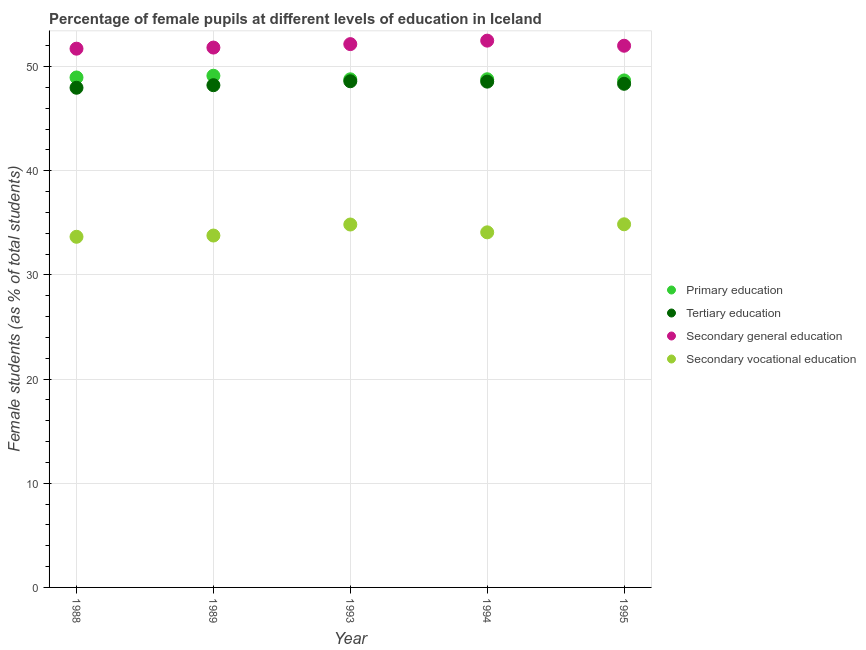Is the number of dotlines equal to the number of legend labels?
Your answer should be very brief. Yes. What is the percentage of female students in secondary vocational education in 1995?
Your answer should be compact. 34.86. Across all years, what is the maximum percentage of female students in primary education?
Your answer should be compact. 49.11. Across all years, what is the minimum percentage of female students in secondary education?
Ensure brevity in your answer.  51.71. In which year was the percentage of female students in tertiary education maximum?
Offer a very short reply. 1993. In which year was the percentage of female students in primary education minimum?
Ensure brevity in your answer.  1995. What is the total percentage of female students in primary education in the graph?
Offer a very short reply. 244.28. What is the difference between the percentage of female students in tertiary education in 1993 and that in 1994?
Offer a very short reply. 0.04. What is the difference between the percentage of female students in secondary vocational education in 1994 and the percentage of female students in tertiary education in 1995?
Your answer should be compact. -14.26. What is the average percentage of female students in secondary education per year?
Your answer should be compact. 52.03. In the year 1989, what is the difference between the percentage of female students in tertiary education and percentage of female students in primary education?
Offer a terse response. -0.91. In how many years, is the percentage of female students in primary education greater than 34 %?
Give a very brief answer. 5. What is the ratio of the percentage of female students in tertiary education in 1988 to that in 1995?
Offer a very short reply. 0.99. Is the percentage of female students in tertiary education in 1989 less than that in 1995?
Your response must be concise. Yes. What is the difference between the highest and the second highest percentage of female students in secondary education?
Give a very brief answer. 0.34. What is the difference between the highest and the lowest percentage of female students in tertiary education?
Ensure brevity in your answer.  0.62. Is the sum of the percentage of female students in primary education in 1988 and 1995 greater than the maximum percentage of female students in secondary education across all years?
Provide a short and direct response. Yes. Is the percentage of female students in secondary education strictly less than the percentage of female students in tertiary education over the years?
Give a very brief answer. No. How many dotlines are there?
Provide a short and direct response. 4. How many years are there in the graph?
Provide a short and direct response. 5. How are the legend labels stacked?
Give a very brief answer. Vertical. What is the title of the graph?
Your answer should be compact. Percentage of female pupils at different levels of education in Iceland. What is the label or title of the Y-axis?
Your answer should be compact. Female students (as % of total students). What is the Female students (as % of total students) of Primary education in 1988?
Give a very brief answer. 48.95. What is the Female students (as % of total students) in Tertiary education in 1988?
Your answer should be compact. 47.96. What is the Female students (as % of total students) in Secondary general education in 1988?
Give a very brief answer. 51.71. What is the Female students (as % of total students) of Secondary vocational education in 1988?
Provide a succinct answer. 33.66. What is the Female students (as % of total students) of Primary education in 1989?
Give a very brief answer. 49.11. What is the Female students (as % of total students) in Tertiary education in 1989?
Keep it short and to the point. 48.21. What is the Female students (as % of total students) in Secondary general education in 1989?
Make the answer very short. 51.82. What is the Female students (as % of total students) of Secondary vocational education in 1989?
Make the answer very short. 33.78. What is the Female students (as % of total students) of Primary education in 1993?
Your answer should be very brief. 48.77. What is the Female students (as % of total students) in Tertiary education in 1993?
Provide a short and direct response. 48.59. What is the Female students (as % of total students) of Secondary general education in 1993?
Make the answer very short. 52.15. What is the Female students (as % of total students) of Secondary vocational education in 1993?
Offer a terse response. 34.83. What is the Female students (as % of total students) in Primary education in 1994?
Your answer should be compact. 48.78. What is the Female students (as % of total students) of Tertiary education in 1994?
Your answer should be compact. 48.55. What is the Female students (as % of total students) in Secondary general education in 1994?
Offer a very short reply. 52.49. What is the Female students (as % of total students) of Secondary vocational education in 1994?
Make the answer very short. 34.08. What is the Female students (as % of total students) of Primary education in 1995?
Offer a terse response. 48.66. What is the Female students (as % of total students) of Tertiary education in 1995?
Provide a succinct answer. 48.34. What is the Female students (as % of total students) in Secondary general education in 1995?
Provide a succinct answer. 52. What is the Female students (as % of total students) of Secondary vocational education in 1995?
Offer a terse response. 34.86. Across all years, what is the maximum Female students (as % of total students) in Primary education?
Provide a succinct answer. 49.11. Across all years, what is the maximum Female students (as % of total students) of Tertiary education?
Your response must be concise. 48.59. Across all years, what is the maximum Female students (as % of total students) in Secondary general education?
Provide a succinct answer. 52.49. Across all years, what is the maximum Female students (as % of total students) of Secondary vocational education?
Keep it short and to the point. 34.86. Across all years, what is the minimum Female students (as % of total students) of Primary education?
Offer a very short reply. 48.66. Across all years, what is the minimum Female students (as % of total students) in Tertiary education?
Give a very brief answer. 47.96. Across all years, what is the minimum Female students (as % of total students) in Secondary general education?
Your answer should be compact. 51.71. Across all years, what is the minimum Female students (as % of total students) of Secondary vocational education?
Give a very brief answer. 33.66. What is the total Female students (as % of total students) of Primary education in the graph?
Your answer should be very brief. 244.28. What is the total Female students (as % of total students) of Tertiary education in the graph?
Keep it short and to the point. 241.65. What is the total Female students (as % of total students) in Secondary general education in the graph?
Your answer should be compact. 260.16. What is the total Female students (as % of total students) in Secondary vocational education in the graph?
Your answer should be very brief. 171.21. What is the difference between the Female students (as % of total students) of Primary education in 1988 and that in 1989?
Provide a succinct answer. -0.17. What is the difference between the Female students (as % of total students) in Tertiary education in 1988 and that in 1989?
Your answer should be compact. -0.25. What is the difference between the Female students (as % of total students) of Secondary general education in 1988 and that in 1989?
Offer a terse response. -0.11. What is the difference between the Female students (as % of total students) of Secondary vocational education in 1988 and that in 1989?
Keep it short and to the point. -0.12. What is the difference between the Female students (as % of total students) of Primary education in 1988 and that in 1993?
Ensure brevity in your answer.  0.18. What is the difference between the Female students (as % of total students) in Tertiary education in 1988 and that in 1993?
Your answer should be compact. -0.62. What is the difference between the Female students (as % of total students) in Secondary general education in 1988 and that in 1993?
Your answer should be compact. -0.44. What is the difference between the Female students (as % of total students) in Secondary vocational education in 1988 and that in 1993?
Your answer should be compact. -1.18. What is the difference between the Female students (as % of total students) in Primary education in 1988 and that in 1994?
Ensure brevity in your answer.  0.17. What is the difference between the Female students (as % of total students) of Tertiary education in 1988 and that in 1994?
Ensure brevity in your answer.  -0.59. What is the difference between the Female students (as % of total students) in Secondary general education in 1988 and that in 1994?
Offer a terse response. -0.77. What is the difference between the Female students (as % of total students) in Secondary vocational education in 1988 and that in 1994?
Your answer should be very brief. -0.43. What is the difference between the Female students (as % of total students) in Primary education in 1988 and that in 1995?
Keep it short and to the point. 0.28. What is the difference between the Female students (as % of total students) of Tertiary education in 1988 and that in 1995?
Your answer should be very brief. -0.38. What is the difference between the Female students (as % of total students) of Secondary general education in 1988 and that in 1995?
Provide a short and direct response. -0.28. What is the difference between the Female students (as % of total students) of Secondary vocational education in 1988 and that in 1995?
Offer a terse response. -1.2. What is the difference between the Female students (as % of total students) of Primary education in 1989 and that in 1993?
Your answer should be very brief. 0.34. What is the difference between the Female students (as % of total students) of Tertiary education in 1989 and that in 1993?
Your answer should be very brief. -0.38. What is the difference between the Female students (as % of total students) in Secondary general education in 1989 and that in 1993?
Provide a succinct answer. -0.33. What is the difference between the Female students (as % of total students) in Secondary vocational education in 1989 and that in 1993?
Give a very brief answer. -1.06. What is the difference between the Female students (as % of total students) of Primary education in 1989 and that in 1994?
Give a very brief answer. 0.34. What is the difference between the Female students (as % of total students) of Tertiary education in 1989 and that in 1994?
Offer a very short reply. -0.34. What is the difference between the Female students (as % of total students) of Secondary general education in 1989 and that in 1994?
Provide a short and direct response. -0.67. What is the difference between the Female students (as % of total students) of Secondary vocational education in 1989 and that in 1994?
Your answer should be compact. -0.31. What is the difference between the Female students (as % of total students) of Primary education in 1989 and that in 1995?
Your answer should be very brief. 0.45. What is the difference between the Female students (as % of total students) of Tertiary education in 1989 and that in 1995?
Your response must be concise. -0.13. What is the difference between the Female students (as % of total students) of Secondary general education in 1989 and that in 1995?
Ensure brevity in your answer.  -0.18. What is the difference between the Female students (as % of total students) in Secondary vocational education in 1989 and that in 1995?
Ensure brevity in your answer.  -1.08. What is the difference between the Female students (as % of total students) of Primary education in 1993 and that in 1994?
Offer a very short reply. -0.01. What is the difference between the Female students (as % of total students) in Tertiary education in 1993 and that in 1994?
Your response must be concise. 0.04. What is the difference between the Female students (as % of total students) of Secondary general education in 1993 and that in 1994?
Your answer should be very brief. -0.34. What is the difference between the Female students (as % of total students) in Secondary vocational education in 1993 and that in 1994?
Your response must be concise. 0.75. What is the difference between the Female students (as % of total students) in Primary education in 1993 and that in 1995?
Your answer should be very brief. 0.11. What is the difference between the Female students (as % of total students) of Tertiary education in 1993 and that in 1995?
Offer a terse response. 0.24. What is the difference between the Female students (as % of total students) of Secondary general education in 1993 and that in 1995?
Make the answer very short. 0.16. What is the difference between the Female students (as % of total students) of Secondary vocational education in 1993 and that in 1995?
Your answer should be compact. -0.02. What is the difference between the Female students (as % of total students) in Primary education in 1994 and that in 1995?
Provide a succinct answer. 0.11. What is the difference between the Female students (as % of total students) in Tertiary education in 1994 and that in 1995?
Keep it short and to the point. 0.21. What is the difference between the Female students (as % of total students) of Secondary general education in 1994 and that in 1995?
Give a very brief answer. 0.49. What is the difference between the Female students (as % of total students) in Secondary vocational education in 1994 and that in 1995?
Make the answer very short. -0.77. What is the difference between the Female students (as % of total students) in Primary education in 1988 and the Female students (as % of total students) in Tertiary education in 1989?
Your answer should be very brief. 0.74. What is the difference between the Female students (as % of total students) in Primary education in 1988 and the Female students (as % of total students) in Secondary general education in 1989?
Give a very brief answer. -2.87. What is the difference between the Female students (as % of total students) of Primary education in 1988 and the Female students (as % of total students) of Secondary vocational education in 1989?
Give a very brief answer. 15.17. What is the difference between the Female students (as % of total students) in Tertiary education in 1988 and the Female students (as % of total students) in Secondary general education in 1989?
Your answer should be compact. -3.86. What is the difference between the Female students (as % of total students) in Tertiary education in 1988 and the Female students (as % of total students) in Secondary vocational education in 1989?
Make the answer very short. 14.19. What is the difference between the Female students (as % of total students) of Secondary general education in 1988 and the Female students (as % of total students) of Secondary vocational education in 1989?
Provide a short and direct response. 17.94. What is the difference between the Female students (as % of total students) of Primary education in 1988 and the Female students (as % of total students) of Tertiary education in 1993?
Make the answer very short. 0.36. What is the difference between the Female students (as % of total students) in Primary education in 1988 and the Female students (as % of total students) in Secondary general education in 1993?
Ensure brevity in your answer.  -3.2. What is the difference between the Female students (as % of total students) in Primary education in 1988 and the Female students (as % of total students) in Secondary vocational education in 1993?
Keep it short and to the point. 14.11. What is the difference between the Female students (as % of total students) of Tertiary education in 1988 and the Female students (as % of total students) of Secondary general education in 1993?
Provide a succinct answer. -4.19. What is the difference between the Female students (as % of total students) in Tertiary education in 1988 and the Female students (as % of total students) in Secondary vocational education in 1993?
Provide a short and direct response. 13.13. What is the difference between the Female students (as % of total students) in Secondary general education in 1988 and the Female students (as % of total students) in Secondary vocational education in 1993?
Offer a terse response. 16.88. What is the difference between the Female students (as % of total students) in Primary education in 1988 and the Female students (as % of total students) in Tertiary education in 1994?
Provide a succinct answer. 0.4. What is the difference between the Female students (as % of total students) in Primary education in 1988 and the Female students (as % of total students) in Secondary general education in 1994?
Your response must be concise. -3.54. What is the difference between the Female students (as % of total students) of Primary education in 1988 and the Female students (as % of total students) of Secondary vocational education in 1994?
Give a very brief answer. 14.86. What is the difference between the Female students (as % of total students) in Tertiary education in 1988 and the Female students (as % of total students) in Secondary general education in 1994?
Provide a short and direct response. -4.52. What is the difference between the Female students (as % of total students) of Tertiary education in 1988 and the Female students (as % of total students) of Secondary vocational education in 1994?
Your response must be concise. 13.88. What is the difference between the Female students (as % of total students) in Secondary general education in 1988 and the Female students (as % of total students) in Secondary vocational education in 1994?
Make the answer very short. 17.63. What is the difference between the Female students (as % of total students) in Primary education in 1988 and the Female students (as % of total students) in Tertiary education in 1995?
Keep it short and to the point. 0.61. What is the difference between the Female students (as % of total students) in Primary education in 1988 and the Female students (as % of total students) in Secondary general education in 1995?
Your response must be concise. -3.05. What is the difference between the Female students (as % of total students) of Primary education in 1988 and the Female students (as % of total students) of Secondary vocational education in 1995?
Ensure brevity in your answer.  14.09. What is the difference between the Female students (as % of total students) of Tertiary education in 1988 and the Female students (as % of total students) of Secondary general education in 1995?
Keep it short and to the point. -4.03. What is the difference between the Female students (as % of total students) of Tertiary education in 1988 and the Female students (as % of total students) of Secondary vocational education in 1995?
Provide a short and direct response. 13.1. What is the difference between the Female students (as % of total students) of Secondary general education in 1988 and the Female students (as % of total students) of Secondary vocational education in 1995?
Provide a succinct answer. 16.86. What is the difference between the Female students (as % of total students) of Primary education in 1989 and the Female students (as % of total students) of Tertiary education in 1993?
Your answer should be very brief. 0.53. What is the difference between the Female students (as % of total students) in Primary education in 1989 and the Female students (as % of total students) in Secondary general education in 1993?
Provide a succinct answer. -3.04. What is the difference between the Female students (as % of total students) in Primary education in 1989 and the Female students (as % of total students) in Secondary vocational education in 1993?
Keep it short and to the point. 14.28. What is the difference between the Female students (as % of total students) of Tertiary education in 1989 and the Female students (as % of total students) of Secondary general education in 1993?
Provide a succinct answer. -3.94. What is the difference between the Female students (as % of total students) of Tertiary education in 1989 and the Female students (as % of total students) of Secondary vocational education in 1993?
Keep it short and to the point. 13.37. What is the difference between the Female students (as % of total students) of Secondary general education in 1989 and the Female students (as % of total students) of Secondary vocational education in 1993?
Your answer should be compact. 16.98. What is the difference between the Female students (as % of total students) of Primary education in 1989 and the Female students (as % of total students) of Tertiary education in 1994?
Keep it short and to the point. 0.57. What is the difference between the Female students (as % of total students) of Primary education in 1989 and the Female students (as % of total students) of Secondary general education in 1994?
Offer a very short reply. -3.37. What is the difference between the Female students (as % of total students) of Primary education in 1989 and the Female students (as % of total students) of Secondary vocational education in 1994?
Your answer should be compact. 15.03. What is the difference between the Female students (as % of total students) in Tertiary education in 1989 and the Female students (as % of total students) in Secondary general education in 1994?
Provide a succinct answer. -4.28. What is the difference between the Female students (as % of total students) of Tertiary education in 1989 and the Female students (as % of total students) of Secondary vocational education in 1994?
Offer a terse response. 14.12. What is the difference between the Female students (as % of total students) of Secondary general education in 1989 and the Female students (as % of total students) of Secondary vocational education in 1994?
Make the answer very short. 17.73. What is the difference between the Female students (as % of total students) of Primary education in 1989 and the Female students (as % of total students) of Tertiary education in 1995?
Your answer should be compact. 0.77. What is the difference between the Female students (as % of total students) in Primary education in 1989 and the Female students (as % of total students) in Secondary general education in 1995?
Make the answer very short. -2.88. What is the difference between the Female students (as % of total students) of Primary education in 1989 and the Female students (as % of total students) of Secondary vocational education in 1995?
Offer a terse response. 14.26. What is the difference between the Female students (as % of total students) of Tertiary education in 1989 and the Female students (as % of total students) of Secondary general education in 1995?
Provide a succinct answer. -3.79. What is the difference between the Female students (as % of total students) in Tertiary education in 1989 and the Female students (as % of total students) in Secondary vocational education in 1995?
Ensure brevity in your answer.  13.35. What is the difference between the Female students (as % of total students) in Secondary general education in 1989 and the Female students (as % of total students) in Secondary vocational education in 1995?
Provide a short and direct response. 16.96. What is the difference between the Female students (as % of total students) in Primary education in 1993 and the Female students (as % of total students) in Tertiary education in 1994?
Your response must be concise. 0.22. What is the difference between the Female students (as % of total students) in Primary education in 1993 and the Female students (as % of total students) in Secondary general education in 1994?
Provide a short and direct response. -3.71. What is the difference between the Female students (as % of total students) in Primary education in 1993 and the Female students (as % of total students) in Secondary vocational education in 1994?
Make the answer very short. 14.69. What is the difference between the Female students (as % of total students) of Tertiary education in 1993 and the Female students (as % of total students) of Secondary general education in 1994?
Make the answer very short. -3.9. What is the difference between the Female students (as % of total students) in Tertiary education in 1993 and the Female students (as % of total students) in Secondary vocational education in 1994?
Your answer should be compact. 14.5. What is the difference between the Female students (as % of total students) of Secondary general education in 1993 and the Female students (as % of total students) of Secondary vocational education in 1994?
Give a very brief answer. 18.07. What is the difference between the Female students (as % of total students) in Primary education in 1993 and the Female students (as % of total students) in Tertiary education in 1995?
Keep it short and to the point. 0.43. What is the difference between the Female students (as % of total students) of Primary education in 1993 and the Female students (as % of total students) of Secondary general education in 1995?
Offer a very short reply. -3.22. What is the difference between the Female students (as % of total students) of Primary education in 1993 and the Female students (as % of total students) of Secondary vocational education in 1995?
Offer a very short reply. 13.91. What is the difference between the Female students (as % of total students) in Tertiary education in 1993 and the Female students (as % of total students) in Secondary general education in 1995?
Your answer should be very brief. -3.41. What is the difference between the Female students (as % of total students) of Tertiary education in 1993 and the Female students (as % of total students) of Secondary vocational education in 1995?
Offer a very short reply. 13.73. What is the difference between the Female students (as % of total students) of Secondary general education in 1993 and the Female students (as % of total students) of Secondary vocational education in 1995?
Provide a short and direct response. 17.29. What is the difference between the Female students (as % of total students) in Primary education in 1994 and the Female students (as % of total students) in Tertiary education in 1995?
Offer a very short reply. 0.44. What is the difference between the Female students (as % of total students) of Primary education in 1994 and the Female students (as % of total students) of Secondary general education in 1995?
Your answer should be very brief. -3.22. What is the difference between the Female students (as % of total students) of Primary education in 1994 and the Female students (as % of total students) of Secondary vocational education in 1995?
Make the answer very short. 13.92. What is the difference between the Female students (as % of total students) in Tertiary education in 1994 and the Female students (as % of total students) in Secondary general education in 1995?
Offer a terse response. -3.45. What is the difference between the Female students (as % of total students) in Tertiary education in 1994 and the Female students (as % of total students) in Secondary vocational education in 1995?
Ensure brevity in your answer.  13.69. What is the difference between the Female students (as % of total students) in Secondary general education in 1994 and the Female students (as % of total students) in Secondary vocational education in 1995?
Your answer should be very brief. 17.63. What is the average Female students (as % of total students) in Primary education per year?
Your answer should be compact. 48.86. What is the average Female students (as % of total students) in Tertiary education per year?
Offer a very short reply. 48.33. What is the average Female students (as % of total students) in Secondary general education per year?
Provide a short and direct response. 52.03. What is the average Female students (as % of total students) of Secondary vocational education per year?
Give a very brief answer. 34.24. In the year 1988, what is the difference between the Female students (as % of total students) in Primary education and Female students (as % of total students) in Tertiary education?
Provide a succinct answer. 0.99. In the year 1988, what is the difference between the Female students (as % of total students) in Primary education and Female students (as % of total students) in Secondary general education?
Keep it short and to the point. -2.76. In the year 1988, what is the difference between the Female students (as % of total students) in Primary education and Female students (as % of total students) in Secondary vocational education?
Your response must be concise. 15.29. In the year 1988, what is the difference between the Female students (as % of total students) in Tertiary education and Female students (as % of total students) in Secondary general education?
Your response must be concise. -3.75. In the year 1988, what is the difference between the Female students (as % of total students) in Tertiary education and Female students (as % of total students) in Secondary vocational education?
Offer a terse response. 14.3. In the year 1988, what is the difference between the Female students (as % of total students) of Secondary general education and Female students (as % of total students) of Secondary vocational education?
Keep it short and to the point. 18.06. In the year 1989, what is the difference between the Female students (as % of total students) in Primary education and Female students (as % of total students) in Tertiary education?
Provide a short and direct response. 0.91. In the year 1989, what is the difference between the Female students (as % of total students) of Primary education and Female students (as % of total students) of Secondary general education?
Your response must be concise. -2.7. In the year 1989, what is the difference between the Female students (as % of total students) in Primary education and Female students (as % of total students) in Secondary vocational education?
Offer a terse response. 15.34. In the year 1989, what is the difference between the Female students (as % of total students) in Tertiary education and Female students (as % of total students) in Secondary general education?
Your response must be concise. -3.61. In the year 1989, what is the difference between the Female students (as % of total students) in Tertiary education and Female students (as % of total students) in Secondary vocational education?
Provide a succinct answer. 14.43. In the year 1989, what is the difference between the Female students (as % of total students) of Secondary general education and Female students (as % of total students) of Secondary vocational education?
Give a very brief answer. 18.04. In the year 1993, what is the difference between the Female students (as % of total students) in Primary education and Female students (as % of total students) in Tertiary education?
Provide a succinct answer. 0.19. In the year 1993, what is the difference between the Female students (as % of total students) of Primary education and Female students (as % of total students) of Secondary general education?
Provide a succinct answer. -3.38. In the year 1993, what is the difference between the Female students (as % of total students) of Primary education and Female students (as % of total students) of Secondary vocational education?
Ensure brevity in your answer.  13.94. In the year 1993, what is the difference between the Female students (as % of total students) of Tertiary education and Female students (as % of total students) of Secondary general education?
Your answer should be very brief. -3.56. In the year 1993, what is the difference between the Female students (as % of total students) of Tertiary education and Female students (as % of total students) of Secondary vocational education?
Offer a terse response. 13.75. In the year 1993, what is the difference between the Female students (as % of total students) of Secondary general education and Female students (as % of total students) of Secondary vocational education?
Ensure brevity in your answer.  17.32. In the year 1994, what is the difference between the Female students (as % of total students) in Primary education and Female students (as % of total students) in Tertiary education?
Keep it short and to the point. 0.23. In the year 1994, what is the difference between the Female students (as % of total students) in Primary education and Female students (as % of total students) in Secondary general education?
Offer a very short reply. -3.71. In the year 1994, what is the difference between the Female students (as % of total students) in Primary education and Female students (as % of total students) in Secondary vocational education?
Offer a very short reply. 14.69. In the year 1994, what is the difference between the Female students (as % of total students) of Tertiary education and Female students (as % of total students) of Secondary general education?
Give a very brief answer. -3.94. In the year 1994, what is the difference between the Female students (as % of total students) in Tertiary education and Female students (as % of total students) in Secondary vocational education?
Your response must be concise. 14.47. In the year 1994, what is the difference between the Female students (as % of total students) in Secondary general education and Female students (as % of total students) in Secondary vocational education?
Make the answer very short. 18.4. In the year 1995, what is the difference between the Female students (as % of total students) of Primary education and Female students (as % of total students) of Tertiary education?
Provide a succinct answer. 0.32. In the year 1995, what is the difference between the Female students (as % of total students) of Primary education and Female students (as % of total students) of Secondary general education?
Offer a very short reply. -3.33. In the year 1995, what is the difference between the Female students (as % of total students) of Primary education and Female students (as % of total students) of Secondary vocational education?
Your answer should be compact. 13.81. In the year 1995, what is the difference between the Female students (as % of total students) of Tertiary education and Female students (as % of total students) of Secondary general education?
Provide a succinct answer. -3.65. In the year 1995, what is the difference between the Female students (as % of total students) in Tertiary education and Female students (as % of total students) in Secondary vocational education?
Provide a succinct answer. 13.49. In the year 1995, what is the difference between the Female students (as % of total students) of Secondary general education and Female students (as % of total students) of Secondary vocational education?
Provide a short and direct response. 17.14. What is the ratio of the Female students (as % of total students) of Tertiary education in 1988 to that in 1989?
Your answer should be very brief. 0.99. What is the ratio of the Female students (as % of total students) in Tertiary education in 1988 to that in 1993?
Your answer should be very brief. 0.99. What is the ratio of the Female students (as % of total students) of Secondary vocational education in 1988 to that in 1993?
Offer a terse response. 0.97. What is the ratio of the Female students (as % of total students) in Primary education in 1988 to that in 1994?
Ensure brevity in your answer.  1. What is the ratio of the Female students (as % of total students) in Tertiary education in 1988 to that in 1994?
Keep it short and to the point. 0.99. What is the ratio of the Female students (as % of total students) in Secondary vocational education in 1988 to that in 1994?
Ensure brevity in your answer.  0.99. What is the ratio of the Female students (as % of total students) in Tertiary education in 1988 to that in 1995?
Give a very brief answer. 0.99. What is the ratio of the Female students (as % of total students) of Secondary general education in 1988 to that in 1995?
Offer a very short reply. 0.99. What is the ratio of the Female students (as % of total students) in Secondary vocational education in 1988 to that in 1995?
Your response must be concise. 0.97. What is the ratio of the Female students (as % of total students) of Secondary vocational education in 1989 to that in 1993?
Keep it short and to the point. 0.97. What is the ratio of the Female students (as % of total students) in Tertiary education in 1989 to that in 1994?
Keep it short and to the point. 0.99. What is the ratio of the Female students (as % of total students) of Secondary general education in 1989 to that in 1994?
Your answer should be very brief. 0.99. What is the ratio of the Female students (as % of total students) of Primary education in 1989 to that in 1995?
Provide a short and direct response. 1.01. What is the ratio of the Female students (as % of total students) in Tertiary education in 1989 to that in 1995?
Provide a succinct answer. 1. What is the ratio of the Female students (as % of total students) in Secondary general education in 1989 to that in 1995?
Keep it short and to the point. 1. What is the ratio of the Female students (as % of total students) in Secondary vocational education in 1989 to that in 1995?
Provide a short and direct response. 0.97. What is the ratio of the Female students (as % of total students) in Tertiary education in 1993 to that in 1994?
Make the answer very short. 1. What is the ratio of the Female students (as % of total students) in Tertiary education in 1993 to that in 1995?
Keep it short and to the point. 1. What is the ratio of the Female students (as % of total students) in Secondary general education in 1993 to that in 1995?
Give a very brief answer. 1. What is the ratio of the Female students (as % of total students) of Secondary vocational education in 1993 to that in 1995?
Offer a terse response. 1. What is the ratio of the Female students (as % of total students) in Secondary general education in 1994 to that in 1995?
Keep it short and to the point. 1.01. What is the ratio of the Female students (as % of total students) of Secondary vocational education in 1994 to that in 1995?
Ensure brevity in your answer.  0.98. What is the difference between the highest and the second highest Female students (as % of total students) in Primary education?
Provide a short and direct response. 0.17. What is the difference between the highest and the second highest Female students (as % of total students) in Tertiary education?
Your answer should be compact. 0.04. What is the difference between the highest and the second highest Female students (as % of total students) of Secondary general education?
Offer a very short reply. 0.34. What is the difference between the highest and the second highest Female students (as % of total students) of Secondary vocational education?
Offer a very short reply. 0.02. What is the difference between the highest and the lowest Female students (as % of total students) in Primary education?
Provide a succinct answer. 0.45. What is the difference between the highest and the lowest Female students (as % of total students) of Tertiary education?
Your answer should be compact. 0.62. What is the difference between the highest and the lowest Female students (as % of total students) in Secondary general education?
Your answer should be very brief. 0.77. What is the difference between the highest and the lowest Female students (as % of total students) in Secondary vocational education?
Make the answer very short. 1.2. 